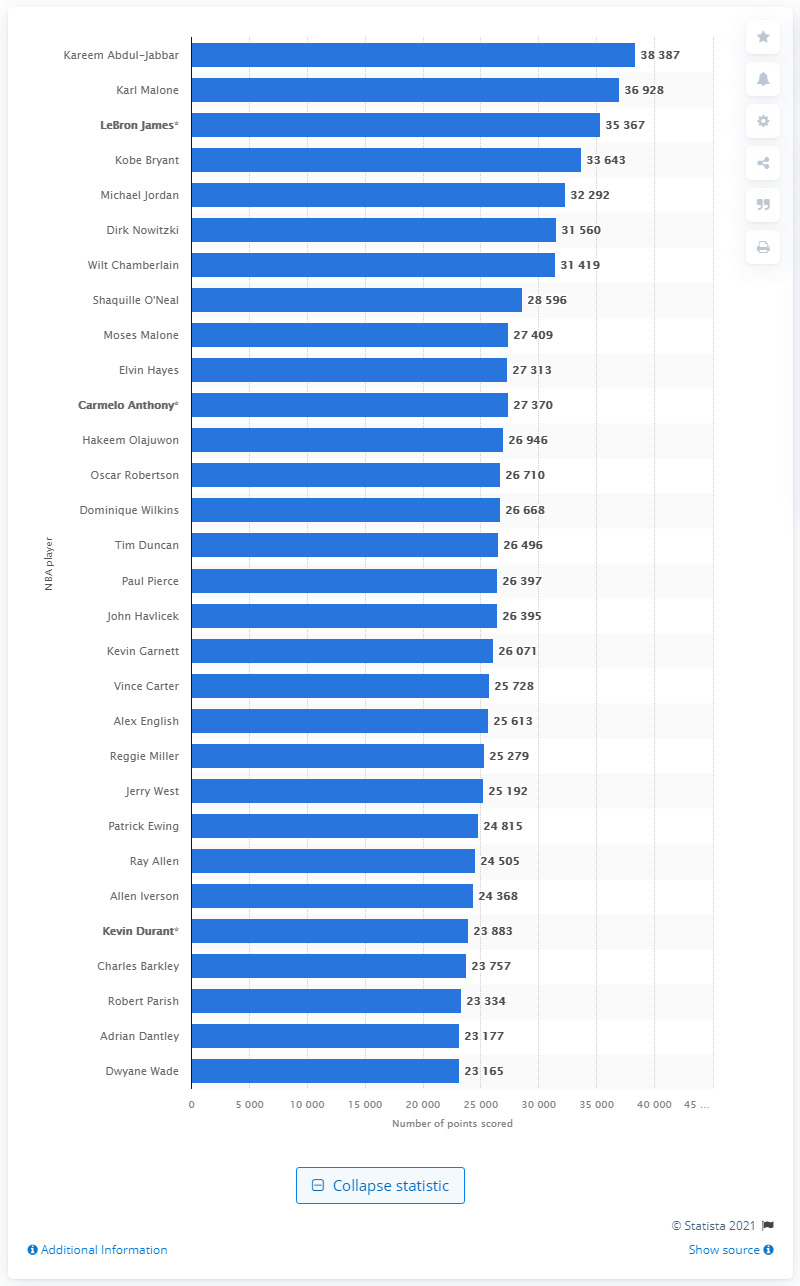Can you tell me about the player who is second on the NBA all-time scoring list? Certainly! The second-place spot on the NBA all-time scoring list is held by Karl Malone, who scored a remarkable total of 36,928 points over the course of his career. 